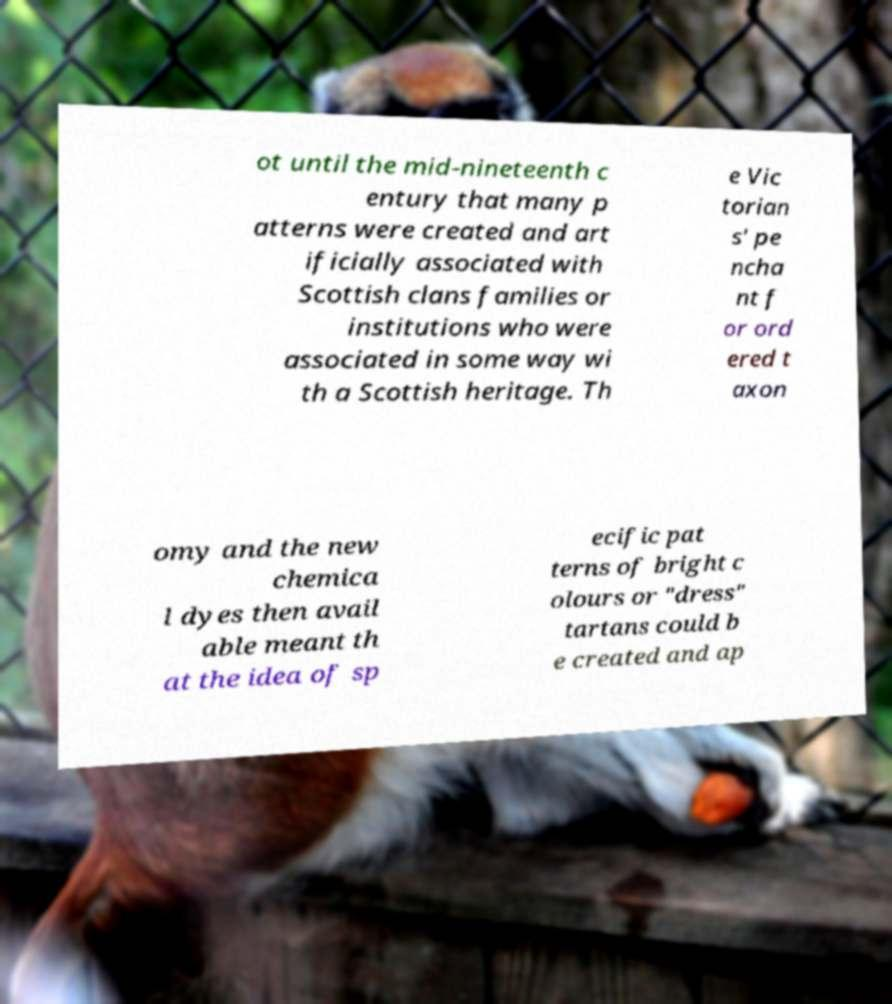There's text embedded in this image that I need extracted. Can you transcribe it verbatim? ot until the mid-nineteenth c entury that many p atterns were created and art ificially associated with Scottish clans families or institutions who were associated in some way wi th a Scottish heritage. Th e Vic torian s' pe ncha nt f or ord ered t axon omy and the new chemica l dyes then avail able meant th at the idea of sp ecific pat terns of bright c olours or "dress" tartans could b e created and ap 